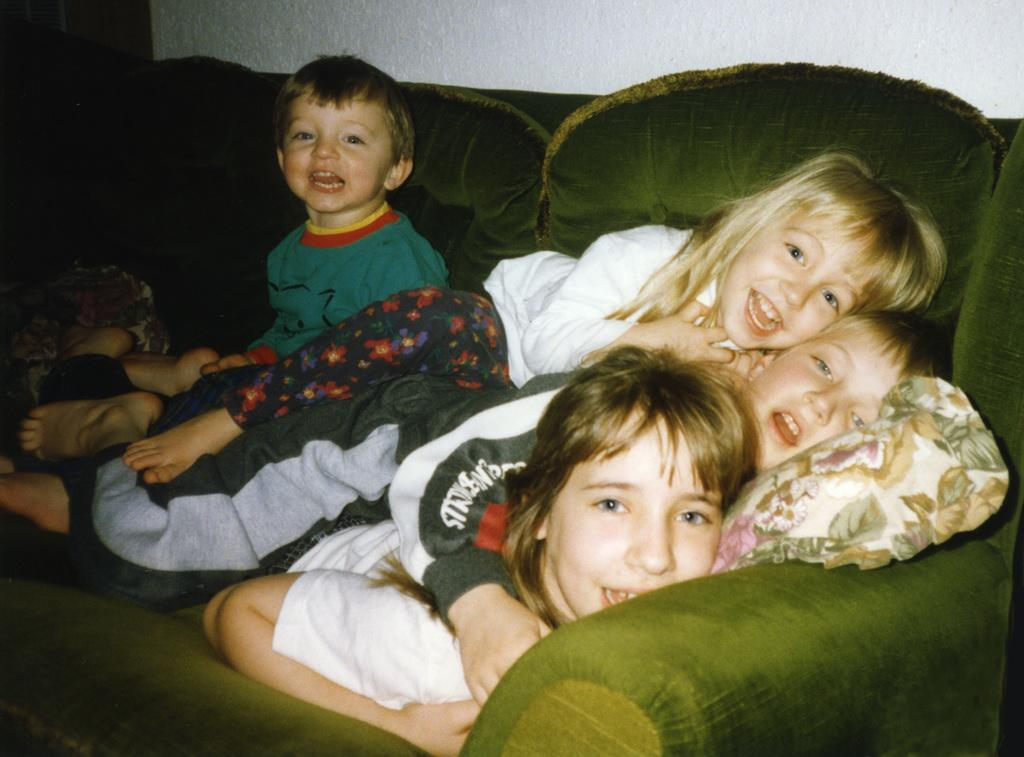What can be seen in the image? There are children in the image. What are the children doing in the image? Some children are lying on the sofa, and one child is sitting. What is visible in the background of the image? There is a wall in the background of the image. What type of suit is the child wearing in the image? There is no mention of a suit in the image, as the children are not wearing any clothing that resembles a suit. 